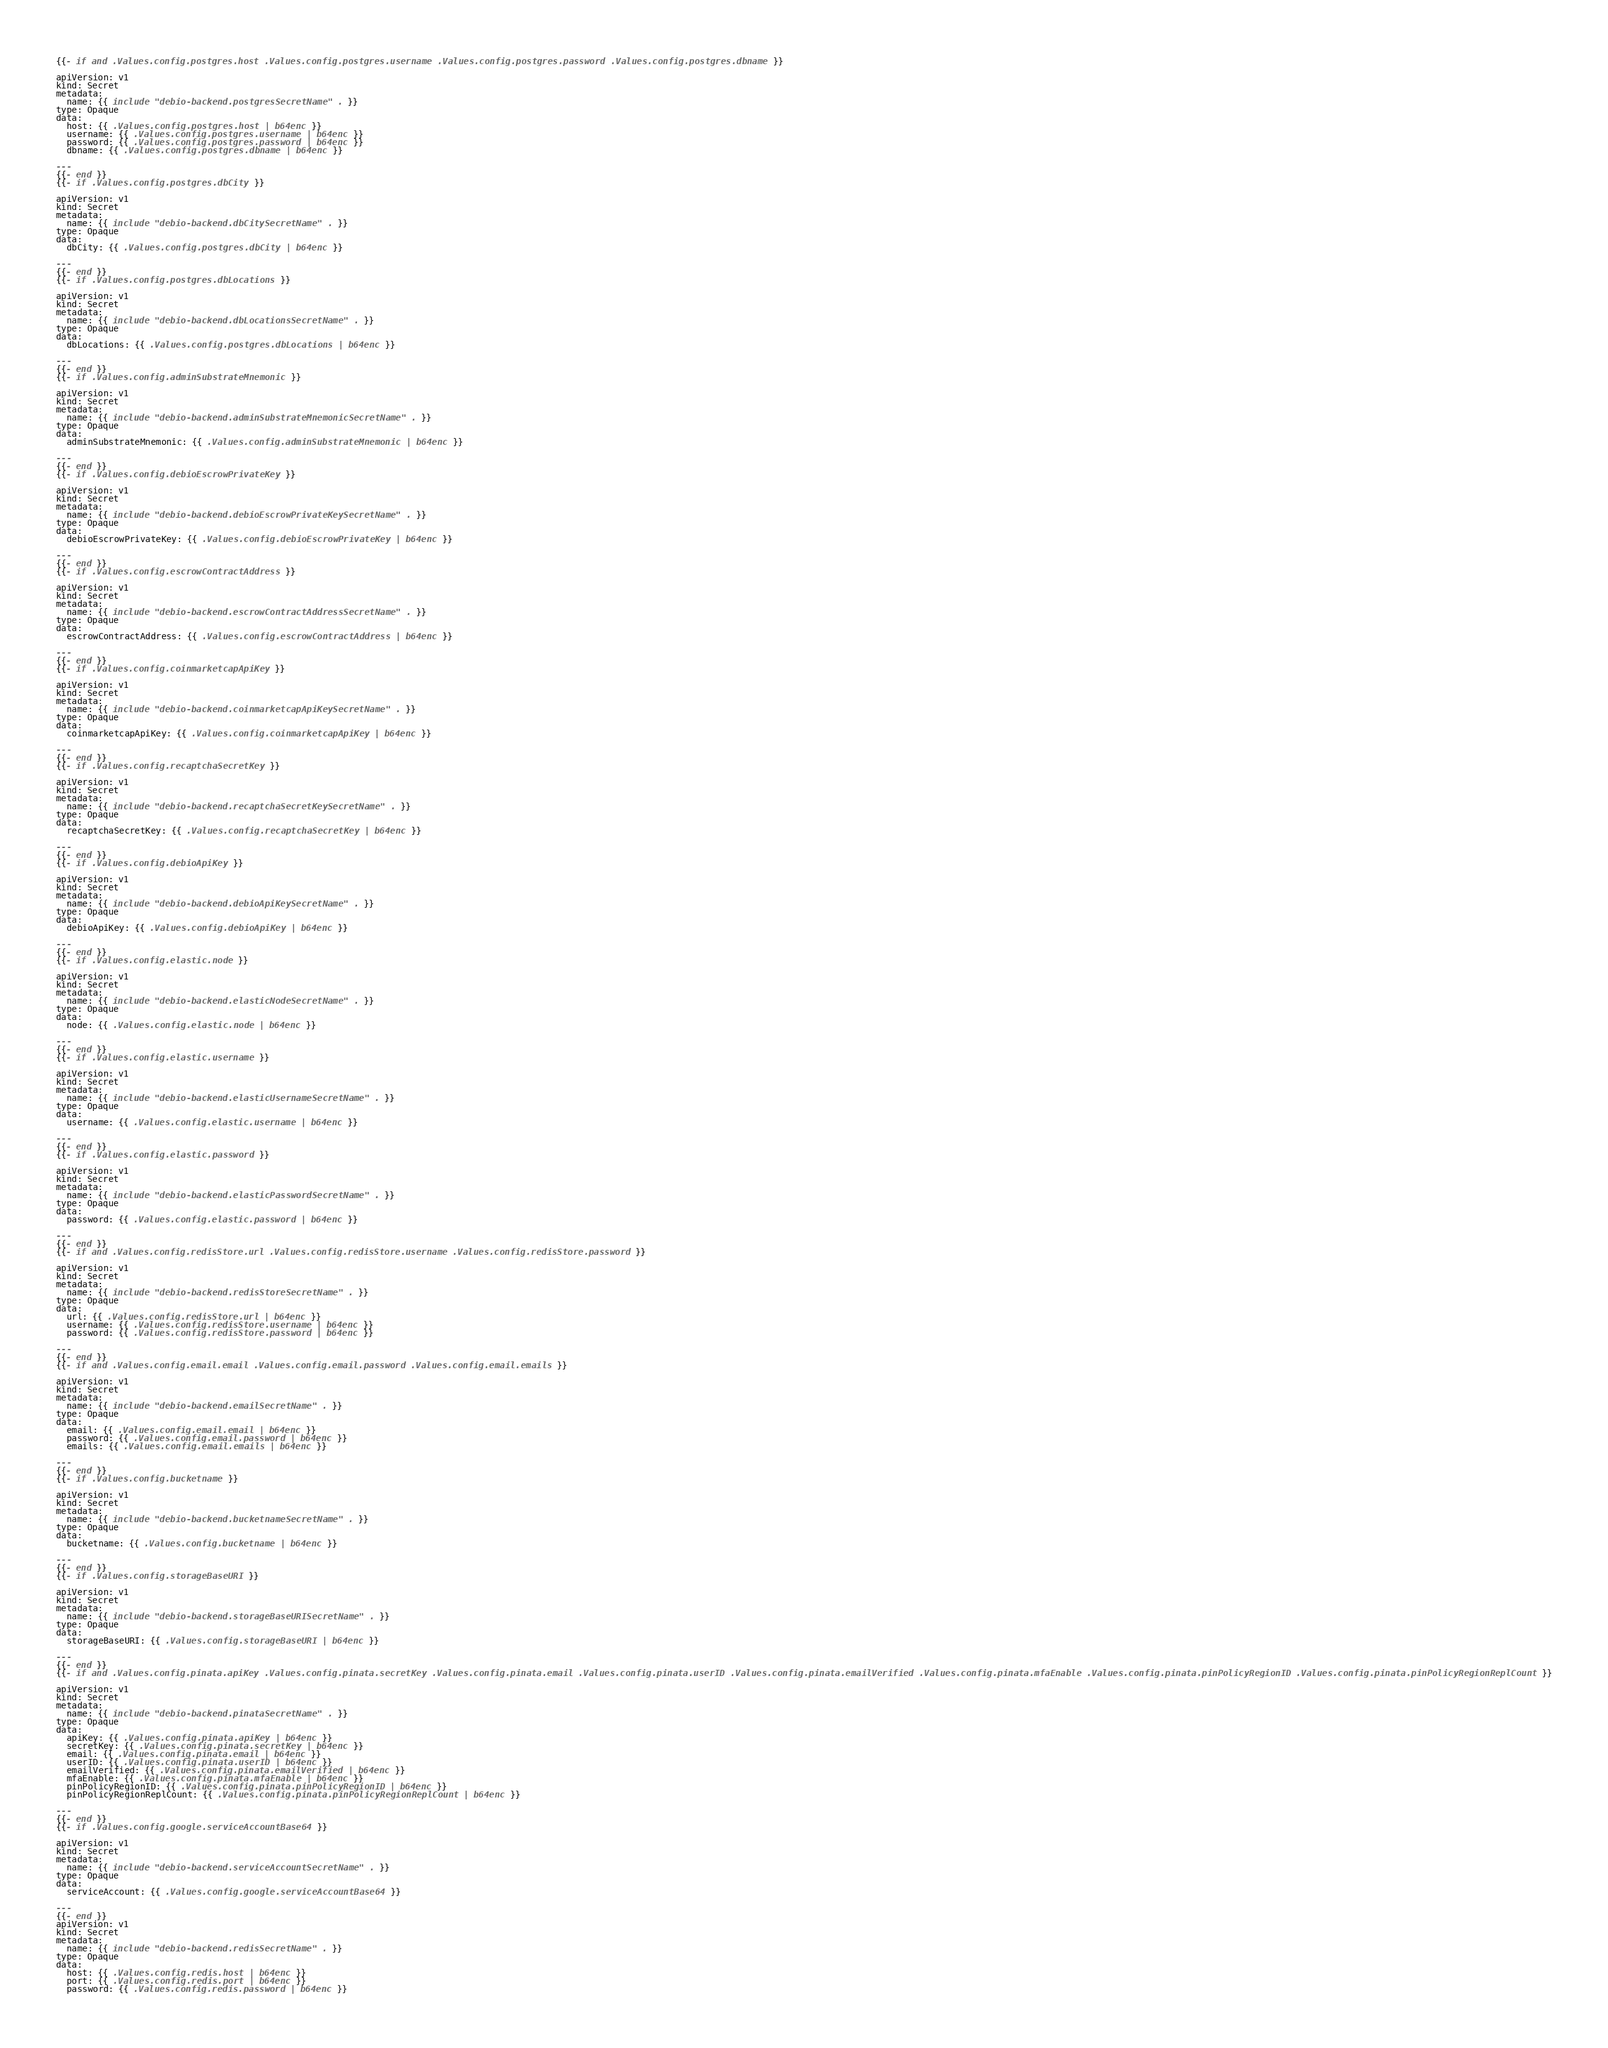<code> <loc_0><loc_0><loc_500><loc_500><_YAML_>{{- if and .Values.config.postgres.host .Values.config.postgres.username .Values.config.postgres.password .Values.config.postgres.dbname }}

apiVersion: v1
kind: Secret
metadata:
  name: {{ include "debio-backend.postgresSecretName" . }}
type: Opaque
data:
  host: {{ .Values.config.postgres.host | b64enc }}
  username: {{ .Values.config.postgres.username | b64enc }}
  password: {{ .Values.config.postgres.password | b64enc }}
  dbname: {{ .Values.config.postgres.dbname | b64enc }}

---
{{- end }}
{{- if .Values.config.postgres.dbCity }}

apiVersion: v1
kind: Secret
metadata:
  name: {{ include "debio-backend.dbCitySecretName" . }}
type: Opaque
data:
  dbCity: {{ .Values.config.postgres.dbCity | b64enc }}

---
{{- end }}
{{- if .Values.config.postgres.dbLocations }}

apiVersion: v1
kind: Secret
metadata:
  name: {{ include "debio-backend.dbLocationsSecretName" . }}
type: Opaque
data:
  dbLocations: {{ .Values.config.postgres.dbLocations | b64enc }}

---
{{- end }}
{{- if .Values.config.adminSubstrateMnemonic }}

apiVersion: v1
kind: Secret
metadata:
  name: {{ include "debio-backend.adminSubstrateMnemonicSecretName" . }}
type: Opaque
data:
  adminSubstrateMnemonic: {{ .Values.config.adminSubstrateMnemonic | b64enc }}

---
{{- end }}
{{- if .Values.config.debioEscrowPrivateKey }}

apiVersion: v1
kind: Secret
metadata:
  name: {{ include "debio-backend.debioEscrowPrivateKeySecretName" . }}
type: Opaque
data:
  debioEscrowPrivateKey: {{ .Values.config.debioEscrowPrivateKey | b64enc }}

---
{{- end }}
{{- if .Values.config.escrowContractAddress }}

apiVersion: v1
kind: Secret
metadata:
  name: {{ include "debio-backend.escrowContractAddressSecretName" . }}
type: Opaque
data:
  escrowContractAddress: {{ .Values.config.escrowContractAddress | b64enc }}

---
{{- end }}
{{- if .Values.config.coinmarketcapApiKey }}

apiVersion: v1
kind: Secret
metadata:
  name: {{ include "debio-backend.coinmarketcapApiKeySecretName" . }}
type: Opaque
data:
  coinmarketcapApiKey: {{ .Values.config.coinmarketcapApiKey | b64enc }}

---
{{- end }}
{{- if .Values.config.recaptchaSecretKey }}

apiVersion: v1
kind: Secret
metadata:
  name: {{ include "debio-backend.recaptchaSecretKeySecretName" . }}
type: Opaque
data:
  recaptchaSecretKey: {{ .Values.config.recaptchaSecretKey | b64enc }}

---
{{- end }}
{{- if .Values.config.debioApiKey }}

apiVersion: v1
kind: Secret
metadata:
  name: {{ include "debio-backend.debioApiKeySecretName" . }}
type: Opaque
data:
  debioApiKey: {{ .Values.config.debioApiKey | b64enc }}

---
{{- end }}
{{- if .Values.config.elastic.node }}

apiVersion: v1
kind: Secret
metadata:
  name: {{ include "debio-backend.elasticNodeSecretName" . }}
type: Opaque
data:
  node: {{ .Values.config.elastic.node | b64enc }}

---
{{- end }}
{{- if .Values.config.elastic.username }}

apiVersion: v1
kind: Secret
metadata:
  name: {{ include "debio-backend.elasticUsernameSecretName" . }}
type: Opaque
data:
  username: {{ .Values.config.elastic.username | b64enc }}

---
{{- end }}
{{- if .Values.config.elastic.password }}

apiVersion: v1
kind: Secret
metadata:
  name: {{ include "debio-backend.elasticPasswordSecretName" . }}
type: Opaque
data:
  password: {{ .Values.config.elastic.password | b64enc }}

---
{{- end }}
{{- if and .Values.config.redisStore.url .Values.config.redisStore.username .Values.config.redisStore.password }}

apiVersion: v1
kind: Secret
metadata:
  name: {{ include "debio-backend.redisStoreSecretName" . }}
type: Opaque
data:
  url: {{ .Values.config.redisStore.url | b64enc }}
  username: {{ .Values.config.redisStore.username | b64enc }}
  password: {{ .Values.config.redisStore.password | b64enc }}

---
{{- end }}
{{- if and .Values.config.email.email .Values.config.email.password .Values.config.email.emails }}

apiVersion: v1
kind: Secret
metadata:
  name: {{ include "debio-backend.emailSecretName" . }}
type: Opaque
data:
  email: {{ .Values.config.email.email | b64enc }}
  password: {{ .Values.config.email.password | b64enc }}
  emails: {{ .Values.config.email.emails | b64enc }}

---
{{- end }}
{{- if .Values.config.bucketname }}

apiVersion: v1
kind: Secret
metadata:
  name: {{ include "debio-backend.bucketnameSecretName" . }}
type: Opaque
data:
  bucketname: {{ .Values.config.bucketname | b64enc }}

---
{{- end }}
{{- if .Values.config.storageBaseURI }}

apiVersion: v1
kind: Secret
metadata:
  name: {{ include "debio-backend.storageBaseURISecretName" . }}
type: Opaque
data:
  storageBaseURI: {{ .Values.config.storageBaseURI | b64enc }}

---
{{- end }}
{{- if and .Values.config.pinata.apiKey .Values.config.pinata.secretKey .Values.config.pinata.email .Values.config.pinata.userID .Values.config.pinata.emailVerified .Values.config.pinata.mfaEnable .Values.config.pinata.pinPolicyRegionID .Values.config.pinata.pinPolicyRegionReplCount }}

apiVersion: v1
kind: Secret
metadata:
  name: {{ include "debio-backend.pinataSecretName" . }}
type: Opaque
data:
  apiKey: {{ .Values.config.pinata.apiKey | b64enc }}
  secretKey: {{ .Values.config.pinata.secretKey | b64enc }}
  email: {{ .Values.config.pinata.email | b64enc }}
  userID: {{ .Values.config.pinata.userID | b64enc }}
  emailVerified: {{ .Values.config.pinata.emailVerified | b64enc }}
  mfaEnable: {{ .Values.config.pinata.mfaEnable | b64enc }}
  pinPolicyRegionID: {{ .Values.config.pinata.pinPolicyRegionID | b64enc }}
  pinPolicyRegionReplCount: {{ .Values.config.pinata.pinPolicyRegionReplCount | b64enc }}

---
{{- end }}
{{- if .Values.config.google.serviceAccountBase64 }}

apiVersion: v1
kind: Secret
metadata:
  name: {{ include "debio-backend.serviceAccountSecretName" . }}
type: Opaque
data:
  serviceAccount: {{ .Values.config.google.serviceAccountBase64 }}

---
{{- end }}
apiVersion: v1
kind: Secret
metadata:
  name: {{ include "debio-backend.redisSecretName" . }}
type: Opaque
data:
  host: {{ .Values.config.redis.host | b64enc }}
  port: {{ .Values.config.redis.port | b64enc }}
  password: {{ .Values.config.redis.password | b64enc }}
</code> 